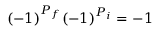Convert formula to latex. <formula><loc_0><loc_0><loc_500><loc_500>( - 1 ) ^ { P _ { f } } ( - 1 ) ^ { P _ { i } } = - 1</formula> 